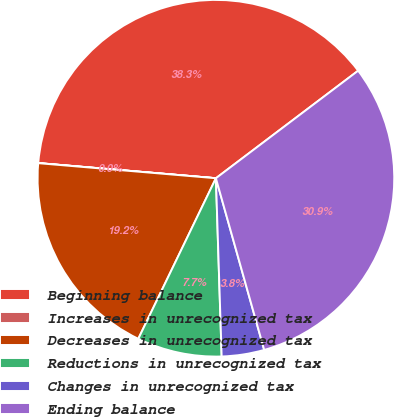Convert chart to OTSL. <chart><loc_0><loc_0><loc_500><loc_500><pie_chart><fcel>Beginning balance<fcel>Increases in unrecognized tax<fcel>Decreases in unrecognized tax<fcel>Reductions in unrecognized tax<fcel>Changes in unrecognized tax<fcel>Ending balance<nl><fcel>38.34%<fcel>0.01%<fcel>19.18%<fcel>7.68%<fcel>3.85%<fcel>30.94%<nl></chart> 